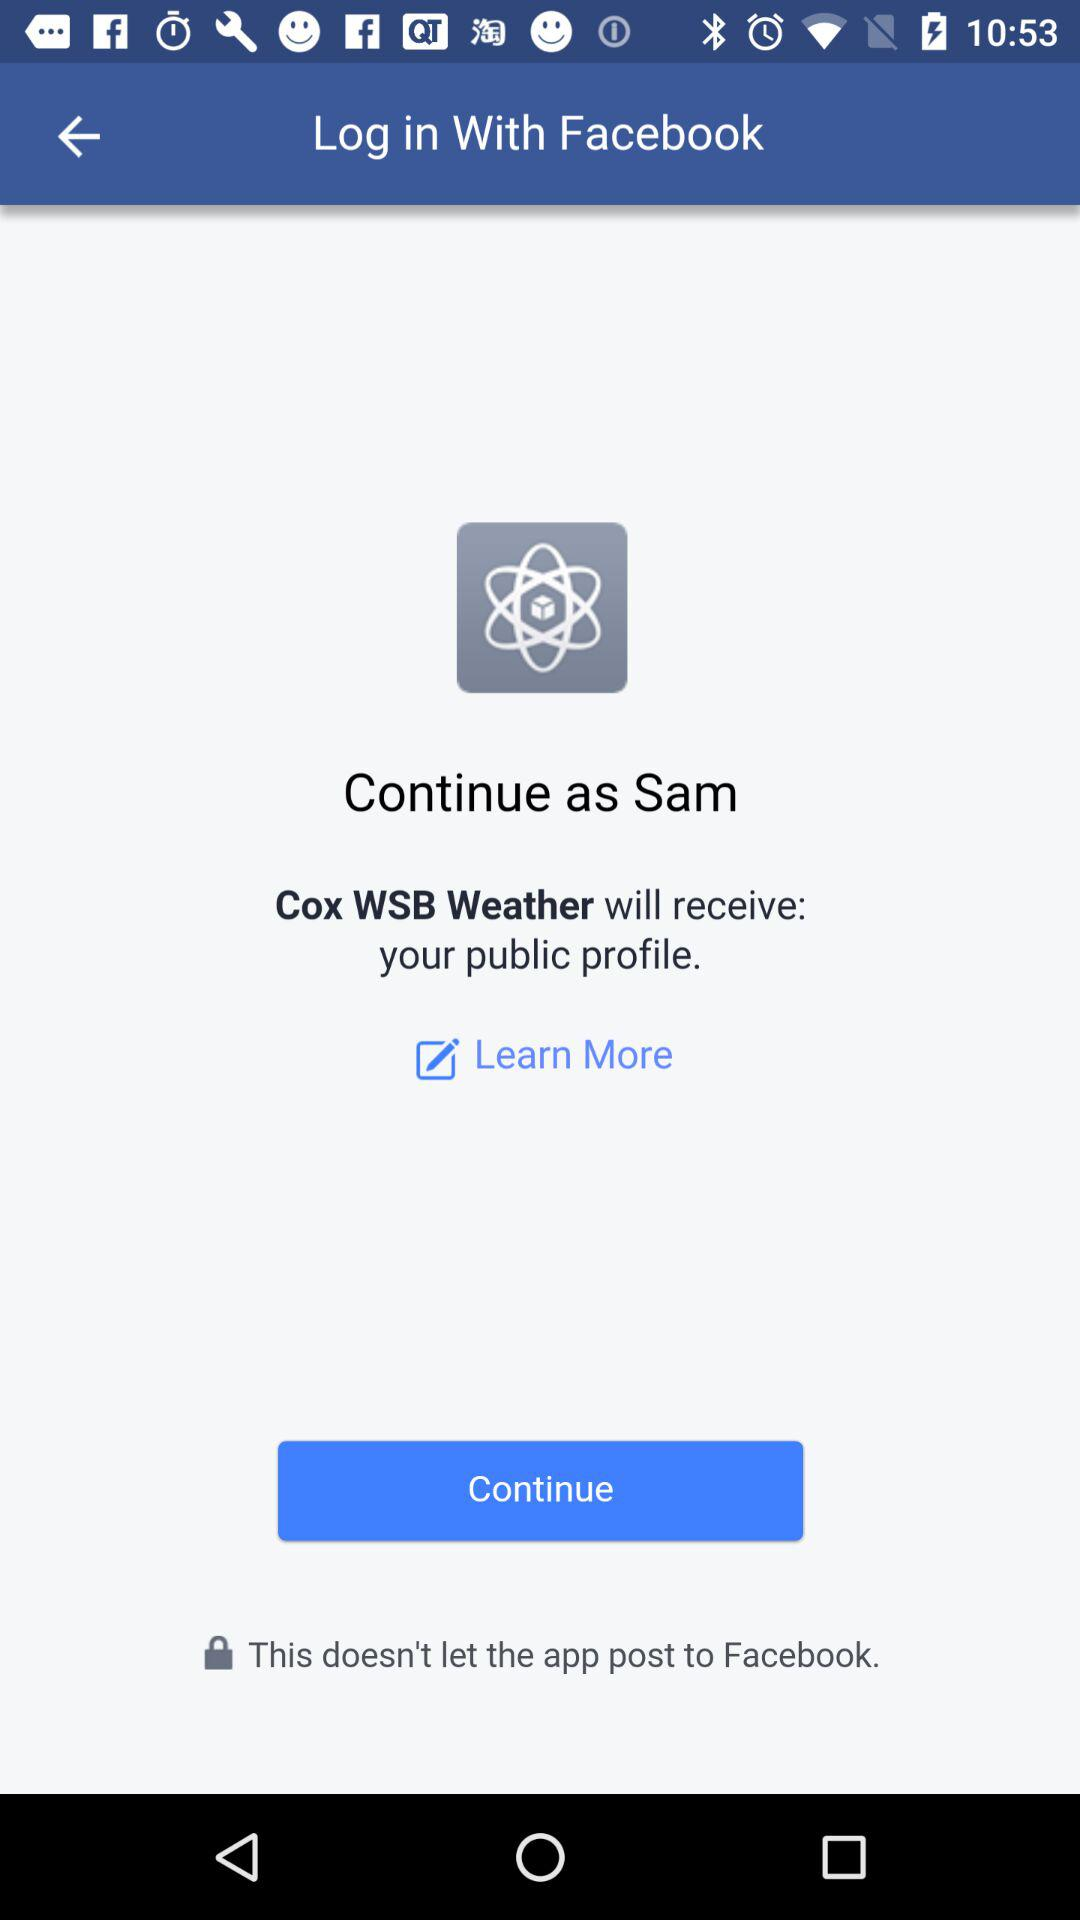What application will receive my public profile? Your public profile will be received by "Cox WSB Weather". 